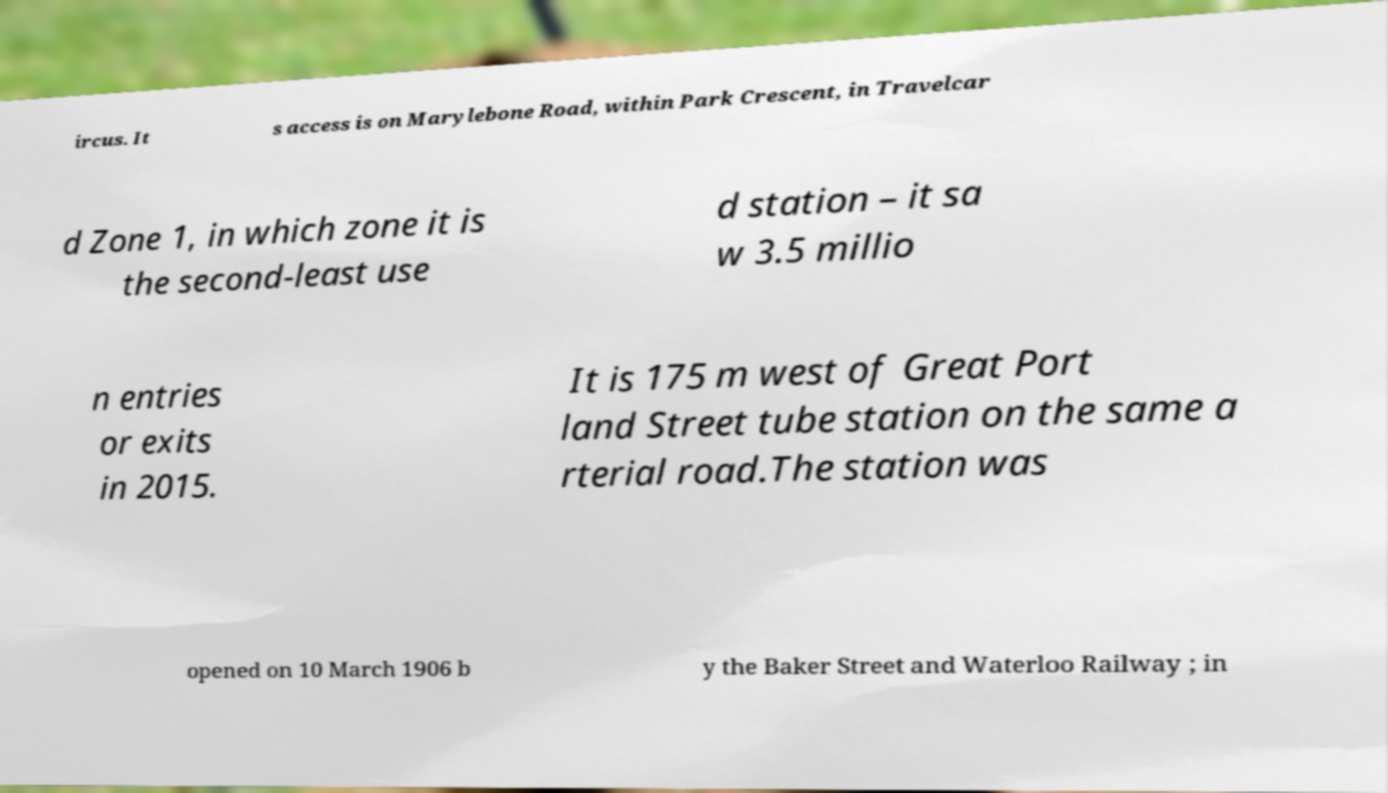Can you read and provide the text displayed in the image?This photo seems to have some interesting text. Can you extract and type it out for me? ircus. It s access is on Marylebone Road, within Park Crescent, in Travelcar d Zone 1, in which zone it is the second-least use d station – it sa w 3.5 millio n entries or exits in 2015. It is 175 m west of Great Port land Street tube station on the same a rterial road.The station was opened on 10 March 1906 b y the Baker Street and Waterloo Railway ; in 